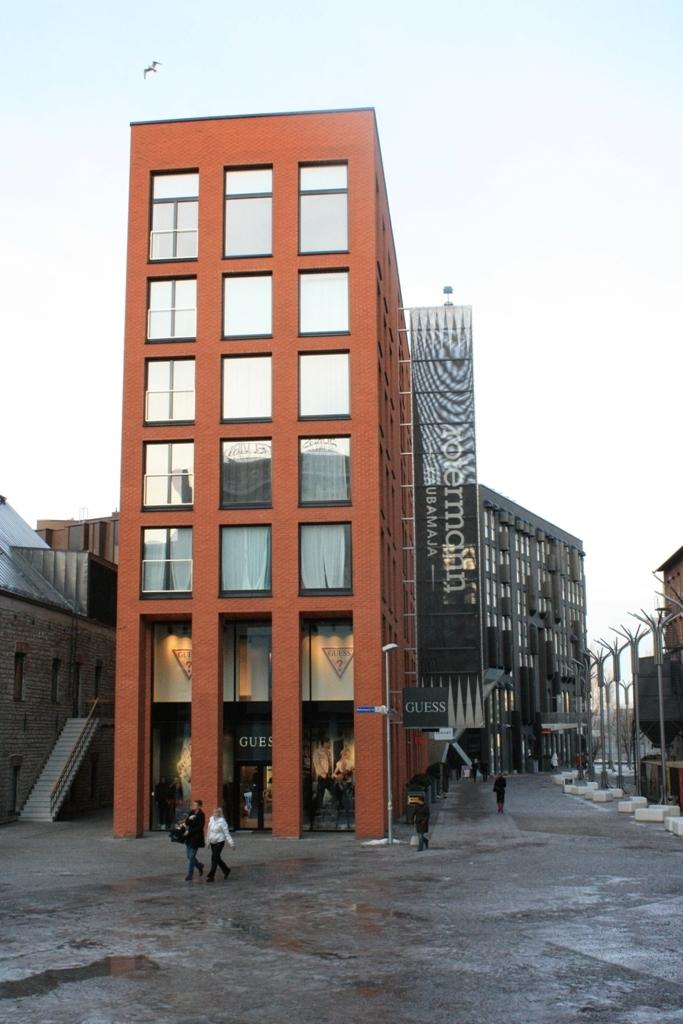What type of structures can be seen in the image? There are buildings in the image. What are the people in the image doing? The people in the image are walking on the road. What is visible at the top of the image? The sky is visible at the top of the image. Can you describe any living creatures in the image? Yes, there is a bird in the image. What time is displayed on the clock tower in the image? There is no clock tower present in the image, so it is not possible to determine the time. Can you describe the type of hook used by the bird in the image? There is no hook present in the image; it features a bird flying in the sky. 